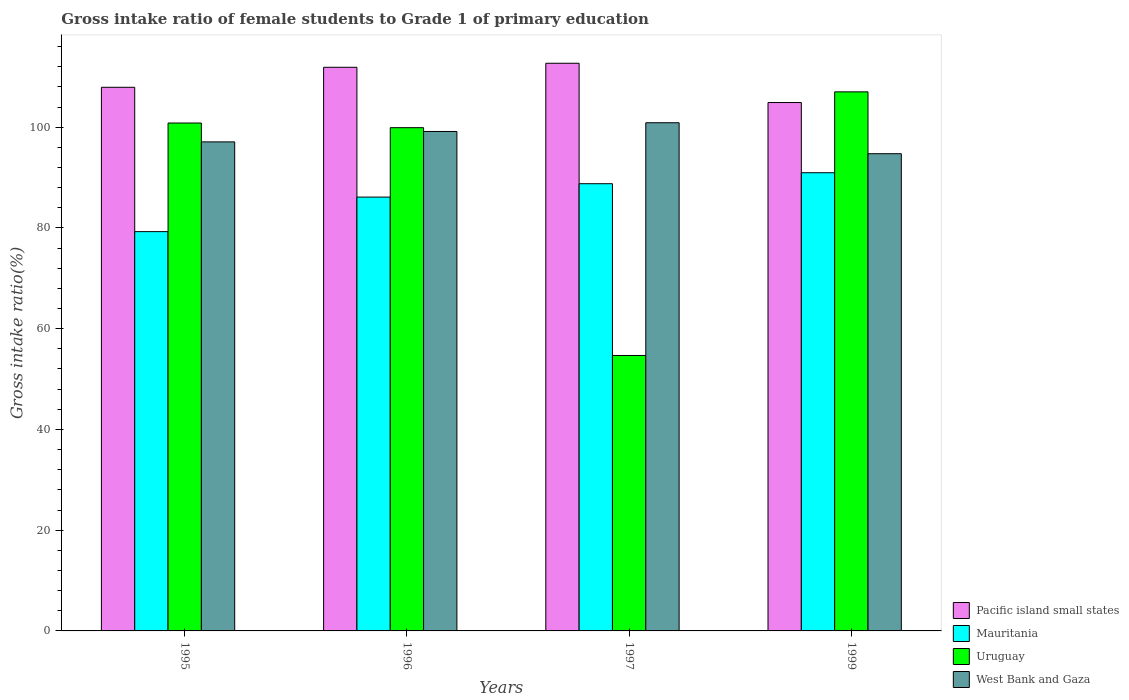Are the number of bars on each tick of the X-axis equal?
Provide a short and direct response. Yes. What is the label of the 2nd group of bars from the left?
Keep it short and to the point. 1996. What is the gross intake ratio in Uruguay in 1997?
Your answer should be very brief. 54.68. Across all years, what is the maximum gross intake ratio in West Bank and Gaza?
Your answer should be compact. 100.89. Across all years, what is the minimum gross intake ratio in Uruguay?
Your response must be concise. 54.68. In which year was the gross intake ratio in West Bank and Gaza maximum?
Provide a short and direct response. 1997. What is the total gross intake ratio in West Bank and Gaza in the graph?
Keep it short and to the point. 391.86. What is the difference between the gross intake ratio in Mauritania in 1995 and that in 1999?
Keep it short and to the point. -11.69. What is the difference between the gross intake ratio in Pacific island small states in 1997 and the gross intake ratio in Uruguay in 1996?
Provide a short and direct response. 12.79. What is the average gross intake ratio in Mauritania per year?
Your response must be concise. 86.29. In the year 1999, what is the difference between the gross intake ratio in Uruguay and gross intake ratio in Pacific island small states?
Your response must be concise. 2.12. What is the ratio of the gross intake ratio in Pacific island small states in 1995 to that in 1997?
Provide a short and direct response. 0.96. Is the gross intake ratio in Uruguay in 1995 less than that in 1999?
Your answer should be very brief. Yes. What is the difference between the highest and the second highest gross intake ratio in Mauritania?
Offer a terse response. 2.18. What is the difference between the highest and the lowest gross intake ratio in Uruguay?
Ensure brevity in your answer.  52.34. Is it the case that in every year, the sum of the gross intake ratio in Mauritania and gross intake ratio in Pacific island small states is greater than the sum of gross intake ratio in West Bank and Gaza and gross intake ratio in Uruguay?
Provide a succinct answer. No. What does the 2nd bar from the left in 1995 represents?
Offer a terse response. Mauritania. What does the 4th bar from the right in 1999 represents?
Your response must be concise. Pacific island small states. Is it the case that in every year, the sum of the gross intake ratio in Mauritania and gross intake ratio in Uruguay is greater than the gross intake ratio in Pacific island small states?
Ensure brevity in your answer.  Yes. Are all the bars in the graph horizontal?
Offer a very short reply. No. What is the difference between two consecutive major ticks on the Y-axis?
Your answer should be compact. 20. Does the graph contain any zero values?
Provide a short and direct response. No. What is the title of the graph?
Your answer should be compact. Gross intake ratio of female students to Grade 1 of primary education. What is the label or title of the X-axis?
Your answer should be very brief. Years. What is the label or title of the Y-axis?
Your answer should be compact. Gross intake ratio(%). What is the Gross intake ratio(%) in Pacific island small states in 1995?
Provide a succinct answer. 107.93. What is the Gross intake ratio(%) in Mauritania in 1995?
Make the answer very short. 79.27. What is the Gross intake ratio(%) of Uruguay in 1995?
Keep it short and to the point. 100.83. What is the Gross intake ratio(%) in West Bank and Gaza in 1995?
Make the answer very short. 97.09. What is the Gross intake ratio(%) of Pacific island small states in 1996?
Your answer should be very brief. 111.89. What is the Gross intake ratio(%) of Mauritania in 1996?
Offer a very short reply. 86.13. What is the Gross intake ratio(%) in Uruguay in 1996?
Your answer should be very brief. 99.91. What is the Gross intake ratio(%) in West Bank and Gaza in 1996?
Provide a succinct answer. 99.15. What is the Gross intake ratio(%) of Pacific island small states in 1997?
Ensure brevity in your answer.  112.7. What is the Gross intake ratio(%) in Mauritania in 1997?
Ensure brevity in your answer.  88.78. What is the Gross intake ratio(%) of Uruguay in 1997?
Offer a very short reply. 54.68. What is the Gross intake ratio(%) in West Bank and Gaza in 1997?
Your answer should be very brief. 100.89. What is the Gross intake ratio(%) in Pacific island small states in 1999?
Ensure brevity in your answer.  104.9. What is the Gross intake ratio(%) of Mauritania in 1999?
Ensure brevity in your answer.  90.96. What is the Gross intake ratio(%) of Uruguay in 1999?
Offer a terse response. 107.02. What is the Gross intake ratio(%) in West Bank and Gaza in 1999?
Offer a terse response. 94.74. Across all years, what is the maximum Gross intake ratio(%) of Pacific island small states?
Your answer should be compact. 112.7. Across all years, what is the maximum Gross intake ratio(%) in Mauritania?
Your answer should be very brief. 90.96. Across all years, what is the maximum Gross intake ratio(%) in Uruguay?
Make the answer very short. 107.02. Across all years, what is the maximum Gross intake ratio(%) of West Bank and Gaza?
Keep it short and to the point. 100.89. Across all years, what is the minimum Gross intake ratio(%) of Pacific island small states?
Your answer should be very brief. 104.9. Across all years, what is the minimum Gross intake ratio(%) in Mauritania?
Provide a short and direct response. 79.27. Across all years, what is the minimum Gross intake ratio(%) of Uruguay?
Make the answer very short. 54.68. Across all years, what is the minimum Gross intake ratio(%) of West Bank and Gaza?
Keep it short and to the point. 94.74. What is the total Gross intake ratio(%) in Pacific island small states in the graph?
Ensure brevity in your answer.  437.42. What is the total Gross intake ratio(%) of Mauritania in the graph?
Your answer should be very brief. 345.14. What is the total Gross intake ratio(%) of Uruguay in the graph?
Provide a short and direct response. 362.44. What is the total Gross intake ratio(%) in West Bank and Gaza in the graph?
Ensure brevity in your answer.  391.87. What is the difference between the Gross intake ratio(%) in Pacific island small states in 1995 and that in 1996?
Offer a very short reply. -3.97. What is the difference between the Gross intake ratio(%) of Mauritania in 1995 and that in 1996?
Ensure brevity in your answer.  -6.86. What is the difference between the Gross intake ratio(%) of Uruguay in 1995 and that in 1996?
Offer a very short reply. 0.93. What is the difference between the Gross intake ratio(%) of West Bank and Gaza in 1995 and that in 1996?
Provide a succinct answer. -2.07. What is the difference between the Gross intake ratio(%) of Pacific island small states in 1995 and that in 1997?
Make the answer very short. -4.77. What is the difference between the Gross intake ratio(%) in Mauritania in 1995 and that in 1997?
Offer a very short reply. -9.51. What is the difference between the Gross intake ratio(%) of Uruguay in 1995 and that in 1997?
Your answer should be very brief. 46.15. What is the difference between the Gross intake ratio(%) in West Bank and Gaza in 1995 and that in 1997?
Your answer should be compact. -3.8. What is the difference between the Gross intake ratio(%) in Pacific island small states in 1995 and that in 1999?
Provide a short and direct response. 3.03. What is the difference between the Gross intake ratio(%) in Mauritania in 1995 and that in 1999?
Your answer should be very brief. -11.69. What is the difference between the Gross intake ratio(%) in Uruguay in 1995 and that in 1999?
Ensure brevity in your answer.  -6.19. What is the difference between the Gross intake ratio(%) of West Bank and Gaza in 1995 and that in 1999?
Provide a short and direct response. 2.35. What is the difference between the Gross intake ratio(%) in Pacific island small states in 1996 and that in 1997?
Your response must be concise. -0.8. What is the difference between the Gross intake ratio(%) in Mauritania in 1996 and that in 1997?
Offer a very short reply. -2.66. What is the difference between the Gross intake ratio(%) in Uruguay in 1996 and that in 1997?
Make the answer very short. 45.22. What is the difference between the Gross intake ratio(%) in West Bank and Gaza in 1996 and that in 1997?
Make the answer very short. -1.73. What is the difference between the Gross intake ratio(%) of Pacific island small states in 1996 and that in 1999?
Ensure brevity in your answer.  7. What is the difference between the Gross intake ratio(%) of Mauritania in 1996 and that in 1999?
Offer a terse response. -4.84. What is the difference between the Gross intake ratio(%) of Uruguay in 1996 and that in 1999?
Make the answer very short. -7.11. What is the difference between the Gross intake ratio(%) in West Bank and Gaza in 1996 and that in 1999?
Your response must be concise. 4.41. What is the difference between the Gross intake ratio(%) of Pacific island small states in 1997 and that in 1999?
Offer a very short reply. 7.8. What is the difference between the Gross intake ratio(%) of Mauritania in 1997 and that in 1999?
Your response must be concise. -2.18. What is the difference between the Gross intake ratio(%) in Uruguay in 1997 and that in 1999?
Ensure brevity in your answer.  -52.34. What is the difference between the Gross intake ratio(%) in West Bank and Gaza in 1997 and that in 1999?
Your answer should be compact. 6.15. What is the difference between the Gross intake ratio(%) of Pacific island small states in 1995 and the Gross intake ratio(%) of Mauritania in 1996?
Offer a terse response. 21.8. What is the difference between the Gross intake ratio(%) of Pacific island small states in 1995 and the Gross intake ratio(%) of Uruguay in 1996?
Give a very brief answer. 8.02. What is the difference between the Gross intake ratio(%) of Pacific island small states in 1995 and the Gross intake ratio(%) of West Bank and Gaza in 1996?
Provide a short and direct response. 8.77. What is the difference between the Gross intake ratio(%) of Mauritania in 1995 and the Gross intake ratio(%) of Uruguay in 1996?
Offer a very short reply. -20.64. What is the difference between the Gross intake ratio(%) of Mauritania in 1995 and the Gross intake ratio(%) of West Bank and Gaza in 1996?
Provide a short and direct response. -19.88. What is the difference between the Gross intake ratio(%) of Uruguay in 1995 and the Gross intake ratio(%) of West Bank and Gaza in 1996?
Make the answer very short. 1.68. What is the difference between the Gross intake ratio(%) of Pacific island small states in 1995 and the Gross intake ratio(%) of Mauritania in 1997?
Give a very brief answer. 19.14. What is the difference between the Gross intake ratio(%) of Pacific island small states in 1995 and the Gross intake ratio(%) of Uruguay in 1997?
Make the answer very short. 53.24. What is the difference between the Gross intake ratio(%) in Pacific island small states in 1995 and the Gross intake ratio(%) in West Bank and Gaza in 1997?
Offer a terse response. 7.04. What is the difference between the Gross intake ratio(%) of Mauritania in 1995 and the Gross intake ratio(%) of Uruguay in 1997?
Offer a very short reply. 24.59. What is the difference between the Gross intake ratio(%) of Mauritania in 1995 and the Gross intake ratio(%) of West Bank and Gaza in 1997?
Provide a succinct answer. -21.62. What is the difference between the Gross intake ratio(%) in Uruguay in 1995 and the Gross intake ratio(%) in West Bank and Gaza in 1997?
Your response must be concise. -0.06. What is the difference between the Gross intake ratio(%) of Pacific island small states in 1995 and the Gross intake ratio(%) of Mauritania in 1999?
Your response must be concise. 16.96. What is the difference between the Gross intake ratio(%) in Pacific island small states in 1995 and the Gross intake ratio(%) in Uruguay in 1999?
Offer a very short reply. 0.91. What is the difference between the Gross intake ratio(%) of Pacific island small states in 1995 and the Gross intake ratio(%) of West Bank and Gaza in 1999?
Give a very brief answer. 13.19. What is the difference between the Gross intake ratio(%) of Mauritania in 1995 and the Gross intake ratio(%) of Uruguay in 1999?
Offer a very short reply. -27.75. What is the difference between the Gross intake ratio(%) in Mauritania in 1995 and the Gross intake ratio(%) in West Bank and Gaza in 1999?
Your answer should be compact. -15.47. What is the difference between the Gross intake ratio(%) of Uruguay in 1995 and the Gross intake ratio(%) of West Bank and Gaza in 1999?
Provide a succinct answer. 6.09. What is the difference between the Gross intake ratio(%) of Pacific island small states in 1996 and the Gross intake ratio(%) of Mauritania in 1997?
Offer a very short reply. 23.11. What is the difference between the Gross intake ratio(%) in Pacific island small states in 1996 and the Gross intake ratio(%) in Uruguay in 1997?
Provide a succinct answer. 57.21. What is the difference between the Gross intake ratio(%) in Pacific island small states in 1996 and the Gross intake ratio(%) in West Bank and Gaza in 1997?
Your answer should be very brief. 11.01. What is the difference between the Gross intake ratio(%) of Mauritania in 1996 and the Gross intake ratio(%) of Uruguay in 1997?
Make the answer very short. 31.44. What is the difference between the Gross intake ratio(%) in Mauritania in 1996 and the Gross intake ratio(%) in West Bank and Gaza in 1997?
Keep it short and to the point. -14.76. What is the difference between the Gross intake ratio(%) of Uruguay in 1996 and the Gross intake ratio(%) of West Bank and Gaza in 1997?
Ensure brevity in your answer.  -0.98. What is the difference between the Gross intake ratio(%) in Pacific island small states in 1996 and the Gross intake ratio(%) in Mauritania in 1999?
Offer a very short reply. 20.93. What is the difference between the Gross intake ratio(%) of Pacific island small states in 1996 and the Gross intake ratio(%) of Uruguay in 1999?
Provide a succinct answer. 4.87. What is the difference between the Gross intake ratio(%) in Pacific island small states in 1996 and the Gross intake ratio(%) in West Bank and Gaza in 1999?
Keep it short and to the point. 17.16. What is the difference between the Gross intake ratio(%) in Mauritania in 1996 and the Gross intake ratio(%) in Uruguay in 1999?
Make the answer very short. -20.89. What is the difference between the Gross intake ratio(%) of Mauritania in 1996 and the Gross intake ratio(%) of West Bank and Gaza in 1999?
Offer a very short reply. -8.61. What is the difference between the Gross intake ratio(%) of Uruguay in 1996 and the Gross intake ratio(%) of West Bank and Gaza in 1999?
Ensure brevity in your answer.  5.17. What is the difference between the Gross intake ratio(%) in Pacific island small states in 1997 and the Gross intake ratio(%) in Mauritania in 1999?
Give a very brief answer. 21.73. What is the difference between the Gross intake ratio(%) of Pacific island small states in 1997 and the Gross intake ratio(%) of Uruguay in 1999?
Your answer should be very brief. 5.68. What is the difference between the Gross intake ratio(%) in Pacific island small states in 1997 and the Gross intake ratio(%) in West Bank and Gaza in 1999?
Make the answer very short. 17.96. What is the difference between the Gross intake ratio(%) of Mauritania in 1997 and the Gross intake ratio(%) of Uruguay in 1999?
Ensure brevity in your answer.  -18.24. What is the difference between the Gross intake ratio(%) of Mauritania in 1997 and the Gross intake ratio(%) of West Bank and Gaza in 1999?
Your answer should be compact. -5.95. What is the difference between the Gross intake ratio(%) of Uruguay in 1997 and the Gross intake ratio(%) of West Bank and Gaza in 1999?
Keep it short and to the point. -40.05. What is the average Gross intake ratio(%) of Pacific island small states per year?
Ensure brevity in your answer.  109.35. What is the average Gross intake ratio(%) in Mauritania per year?
Keep it short and to the point. 86.29. What is the average Gross intake ratio(%) in Uruguay per year?
Make the answer very short. 90.61. What is the average Gross intake ratio(%) in West Bank and Gaza per year?
Make the answer very short. 97.97. In the year 1995, what is the difference between the Gross intake ratio(%) of Pacific island small states and Gross intake ratio(%) of Mauritania?
Your response must be concise. 28.66. In the year 1995, what is the difference between the Gross intake ratio(%) in Pacific island small states and Gross intake ratio(%) in Uruguay?
Provide a short and direct response. 7.09. In the year 1995, what is the difference between the Gross intake ratio(%) of Pacific island small states and Gross intake ratio(%) of West Bank and Gaza?
Your answer should be very brief. 10.84. In the year 1995, what is the difference between the Gross intake ratio(%) of Mauritania and Gross intake ratio(%) of Uruguay?
Make the answer very short. -21.56. In the year 1995, what is the difference between the Gross intake ratio(%) in Mauritania and Gross intake ratio(%) in West Bank and Gaza?
Offer a terse response. -17.82. In the year 1995, what is the difference between the Gross intake ratio(%) in Uruguay and Gross intake ratio(%) in West Bank and Gaza?
Your answer should be very brief. 3.75. In the year 1996, what is the difference between the Gross intake ratio(%) of Pacific island small states and Gross intake ratio(%) of Mauritania?
Ensure brevity in your answer.  25.77. In the year 1996, what is the difference between the Gross intake ratio(%) of Pacific island small states and Gross intake ratio(%) of Uruguay?
Ensure brevity in your answer.  11.99. In the year 1996, what is the difference between the Gross intake ratio(%) in Pacific island small states and Gross intake ratio(%) in West Bank and Gaza?
Your answer should be compact. 12.74. In the year 1996, what is the difference between the Gross intake ratio(%) in Mauritania and Gross intake ratio(%) in Uruguay?
Offer a terse response. -13.78. In the year 1996, what is the difference between the Gross intake ratio(%) in Mauritania and Gross intake ratio(%) in West Bank and Gaza?
Your response must be concise. -13.03. In the year 1996, what is the difference between the Gross intake ratio(%) of Uruguay and Gross intake ratio(%) of West Bank and Gaza?
Your answer should be very brief. 0.75. In the year 1997, what is the difference between the Gross intake ratio(%) in Pacific island small states and Gross intake ratio(%) in Mauritania?
Your answer should be compact. 23.91. In the year 1997, what is the difference between the Gross intake ratio(%) in Pacific island small states and Gross intake ratio(%) in Uruguay?
Offer a terse response. 58.01. In the year 1997, what is the difference between the Gross intake ratio(%) in Pacific island small states and Gross intake ratio(%) in West Bank and Gaza?
Provide a short and direct response. 11.81. In the year 1997, what is the difference between the Gross intake ratio(%) in Mauritania and Gross intake ratio(%) in Uruguay?
Keep it short and to the point. 34.1. In the year 1997, what is the difference between the Gross intake ratio(%) of Mauritania and Gross intake ratio(%) of West Bank and Gaza?
Your response must be concise. -12.1. In the year 1997, what is the difference between the Gross intake ratio(%) of Uruguay and Gross intake ratio(%) of West Bank and Gaza?
Offer a very short reply. -46.2. In the year 1999, what is the difference between the Gross intake ratio(%) of Pacific island small states and Gross intake ratio(%) of Mauritania?
Your answer should be compact. 13.93. In the year 1999, what is the difference between the Gross intake ratio(%) in Pacific island small states and Gross intake ratio(%) in Uruguay?
Make the answer very short. -2.12. In the year 1999, what is the difference between the Gross intake ratio(%) in Pacific island small states and Gross intake ratio(%) in West Bank and Gaza?
Your answer should be very brief. 10.16. In the year 1999, what is the difference between the Gross intake ratio(%) in Mauritania and Gross intake ratio(%) in Uruguay?
Give a very brief answer. -16.06. In the year 1999, what is the difference between the Gross intake ratio(%) in Mauritania and Gross intake ratio(%) in West Bank and Gaza?
Your response must be concise. -3.78. In the year 1999, what is the difference between the Gross intake ratio(%) in Uruguay and Gross intake ratio(%) in West Bank and Gaza?
Offer a very short reply. 12.28. What is the ratio of the Gross intake ratio(%) in Pacific island small states in 1995 to that in 1996?
Provide a short and direct response. 0.96. What is the ratio of the Gross intake ratio(%) of Mauritania in 1995 to that in 1996?
Provide a succinct answer. 0.92. What is the ratio of the Gross intake ratio(%) in Uruguay in 1995 to that in 1996?
Your response must be concise. 1.01. What is the ratio of the Gross intake ratio(%) of West Bank and Gaza in 1995 to that in 1996?
Your response must be concise. 0.98. What is the ratio of the Gross intake ratio(%) in Pacific island small states in 1995 to that in 1997?
Your answer should be compact. 0.96. What is the ratio of the Gross intake ratio(%) in Mauritania in 1995 to that in 1997?
Offer a very short reply. 0.89. What is the ratio of the Gross intake ratio(%) in Uruguay in 1995 to that in 1997?
Give a very brief answer. 1.84. What is the ratio of the Gross intake ratio(%) of West Bank and Gaza in 1995 to that in 1997?
Make the answer very short. 0.96. What is the ratio of the Gross intake ratio(%) of Pacific island small states in 1995 to that in 1999?
Your answer should be compact. 1.03. What is the ratio of the Gross intake ratio(%) in Mauritania in 1995 to that in 1999?
Make the answer very short. 0.87. What is the ratio of the Gross intake ratio(%) in Uruguay in 1995 to that in 1999?
Your response must be concise. 0.94. What is the ratio of the Gross intake ratio(%) of West Bank and Gaza in 1995 to that in 1999?
Offer a very short reply. 1.02. What is the ratio of the Gross intake ratio(%) in Pacific island small states in 1996 to that in 1997?
Give a very brief answer. 0.99. What is the ratio of the Gross intake ratio(%) in Mauritania in 1996 to that in 1997?
Your response must be concise. 0.97. What is the ratio of the Gross intake ratio(%) in Uruguay in 1996 to that in 1997?
Ensure brevity in your answer.  1.83. What is the ratio of the Gross intake ratio(%) in West Bank and Gaza in 1996 to that in 1997?
Your answer should be very brief. 0.98. What is the ratio of the Gross intake ratio(%) in Pacific island small states in 1996 to that in 1999?
Provide a succinct answer. 1.07. What is the ratio of the Gross intake ratio(%) of Mauritania in 1996 to that in 1999?
Make the answer very short. 0.95. What is the ratio of the Gross intake ratio(%) of Uruguay in 1996 to that in 1999?
Provide a short and direct response. 0.93. What is the ratio of the Gross intake ratio(%) of West Bank and Gaza in 1996 to that in 1999?
Provide a short and direct response. 1.05. What is the ratio of the Gross intake ratio(%) of Pacific island small states in 1997 to that in 1999?
Your answer should be compact. 1.07. What is the ratio of the Gross intake ratio(%) in Uruguay in 1997 to that in 1999?
Make the answer very short. 0.51. What is the ratio of the Gross intake ratio(%) of West Bank and Gaza in 1997 to that in 1999?
Make the answer very short. 1.06. What is the difference between the highest and the second highest Gross intake ratio(%) of Pacific island small states?
Make the answer very short. 0.8. What is the difference between the highest and the second highest Gross intake ratio(%) of Mauritania?
Your answer should be compact. 2.18. What is the difference between the highest and the second highest Gross intake ratio(%) of Uruguay?
Your answer should be very brief. 6.19. What is the difference between the highest and the second highest Gross intake ratio(%) of West Bank and Gaza?
Keep it short and to the point. 1.73. What is the difference between the highest and the lowest Gross intake ratio(%) of Pacific island small states?
Keep it short and to the point. 7.8. What is the difference between the highest and the lowest Gross intake ratio(%) of Mauritania?
Provide a succinct answer. 11.69. What is the difference between the highest and the lowest Gross intake ratio(%) of Uruguay?
Provide a succinct answer. 52.34. What is the difference between the highest and the lowest Gross intake ratio(%) in West Bank and Gaza?
Keep it short and to the point. 6.15. 